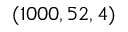<formula> <loc_0><loc_0><loc_500><loc_500>( 1 0 0 0 , 5 2 , 4 )</formula> 